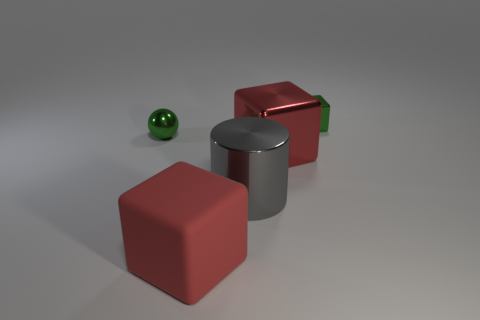Subtract all cyan cubes. Subtract all blue balls. How many cubes are left? 3 Add 2 big gray things. How many objects exist? 7 Subtract all cylinders. How many objects are left? 4 Add 3 big gray shiny cylinders. How many big gray shiny cylinders are left? 4 Add 4 tiny metallic cubes. How many tiny metallic cubes exist? 5 Subtract 0 brown cylinders. How many objects are left? 5 Subtract all green matte balls. Subtract all big shiny cubes. How many objects are left? 4 